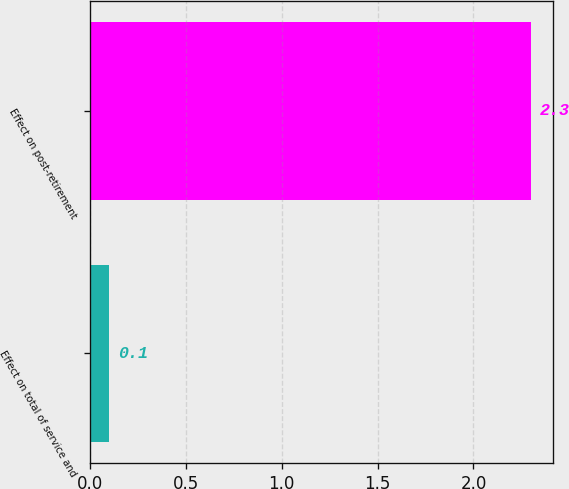<chart> <loc_0><loc_0><loc_500><loc_500><bar_chart><fcel>Effect on total of service and<fcel>Effect on post-retirement<nl><fcel>0.1<fcel>2.3<nl></chart> 